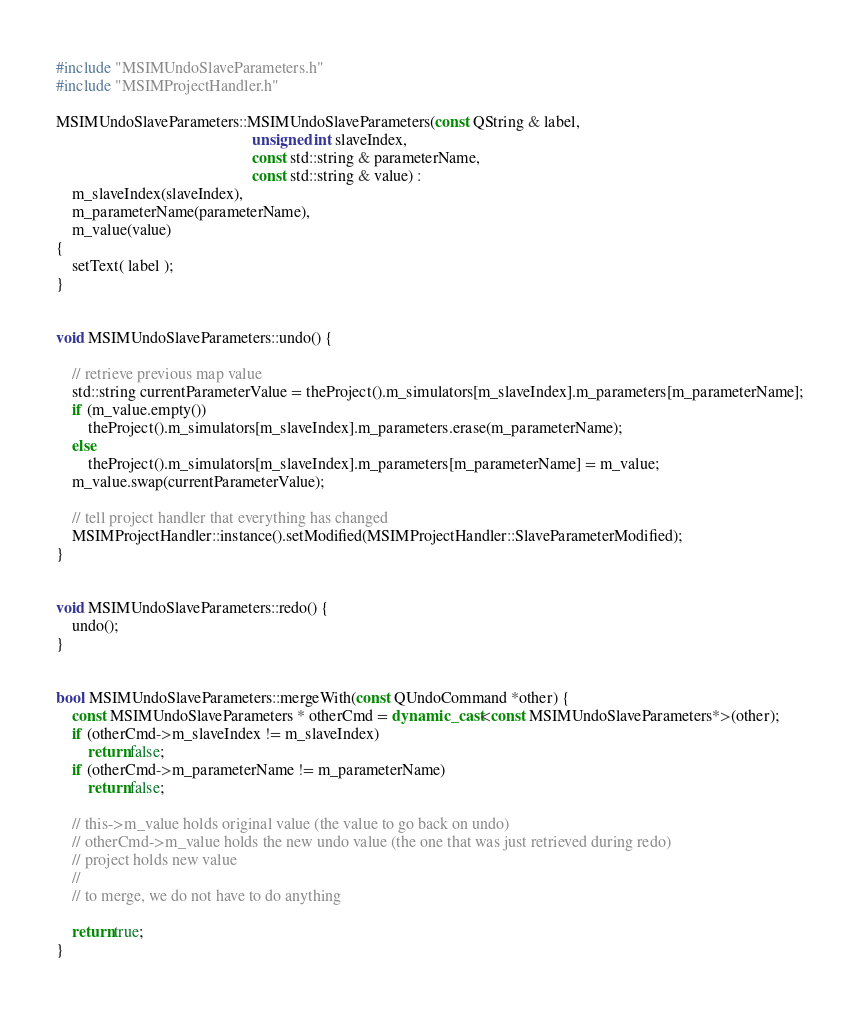<code> <loc_0><loc_0><loc_500><loc_500><_C++_>#include "MSIMUndoSlaveParameters.h"
#include "MSIMProjectHandler.h"

MSIMUndoSlaveParameters::MSIMUndoSlaveParameters(const QString & label,
												 unsigned int slaveIndex,
												 const std::string & parameterName,
												 const std::string & value) :
	m_slaveIndex(slaveIndex),
	m_parameterName(parameterName),
	m_value(value)
{
	setText( label );
}


void MSIMUndoSlaveParameters::undo() {

	// retrieve previous map value
	std::string currentParameterValue = theProject().m_simulators[m_slaveIndex].m_parameters[m_parameterName];
	if (m_value.empty())
		theProject().m_simulators[m_slaveIndex].m_parameters.erase(m_parameterName);
	else
		theProject().m_simulators[m_slaveIndex].m_parameters[m_parameterName] = m_value;
	m_value.swap(currentParameterValue);

	// tell project handler that everything has changed
	MSIMProjectHandler::instance().setModified(MSIMProjectHandler::SlaveParameterModified);
}


void MSIMUndoSlaveParameters::redo() {
	undo();
}


bool MSIMUndoSlaveParameters::mergeWith(const QUndoCommand *other) {
	const MSIMUndoSlaveParameters * otherCmd = dynamic_cast<const MSIMUndoSlaveParameters*>(other);
	if (otherCmd->m_slaveIndex != m_slaveIndex)
		return false;
	if (otherCmd->m_parameterName != m_parameterName)
		return false;

	// this->m_value holds original value (the value to go back on undo)
	// otherCmd->m_value holds the new undo value (the one that was just retrieved during redo)
	// project holds new value
	//
	// to merge, we do not have to do anything

	return true;
}
</code> 